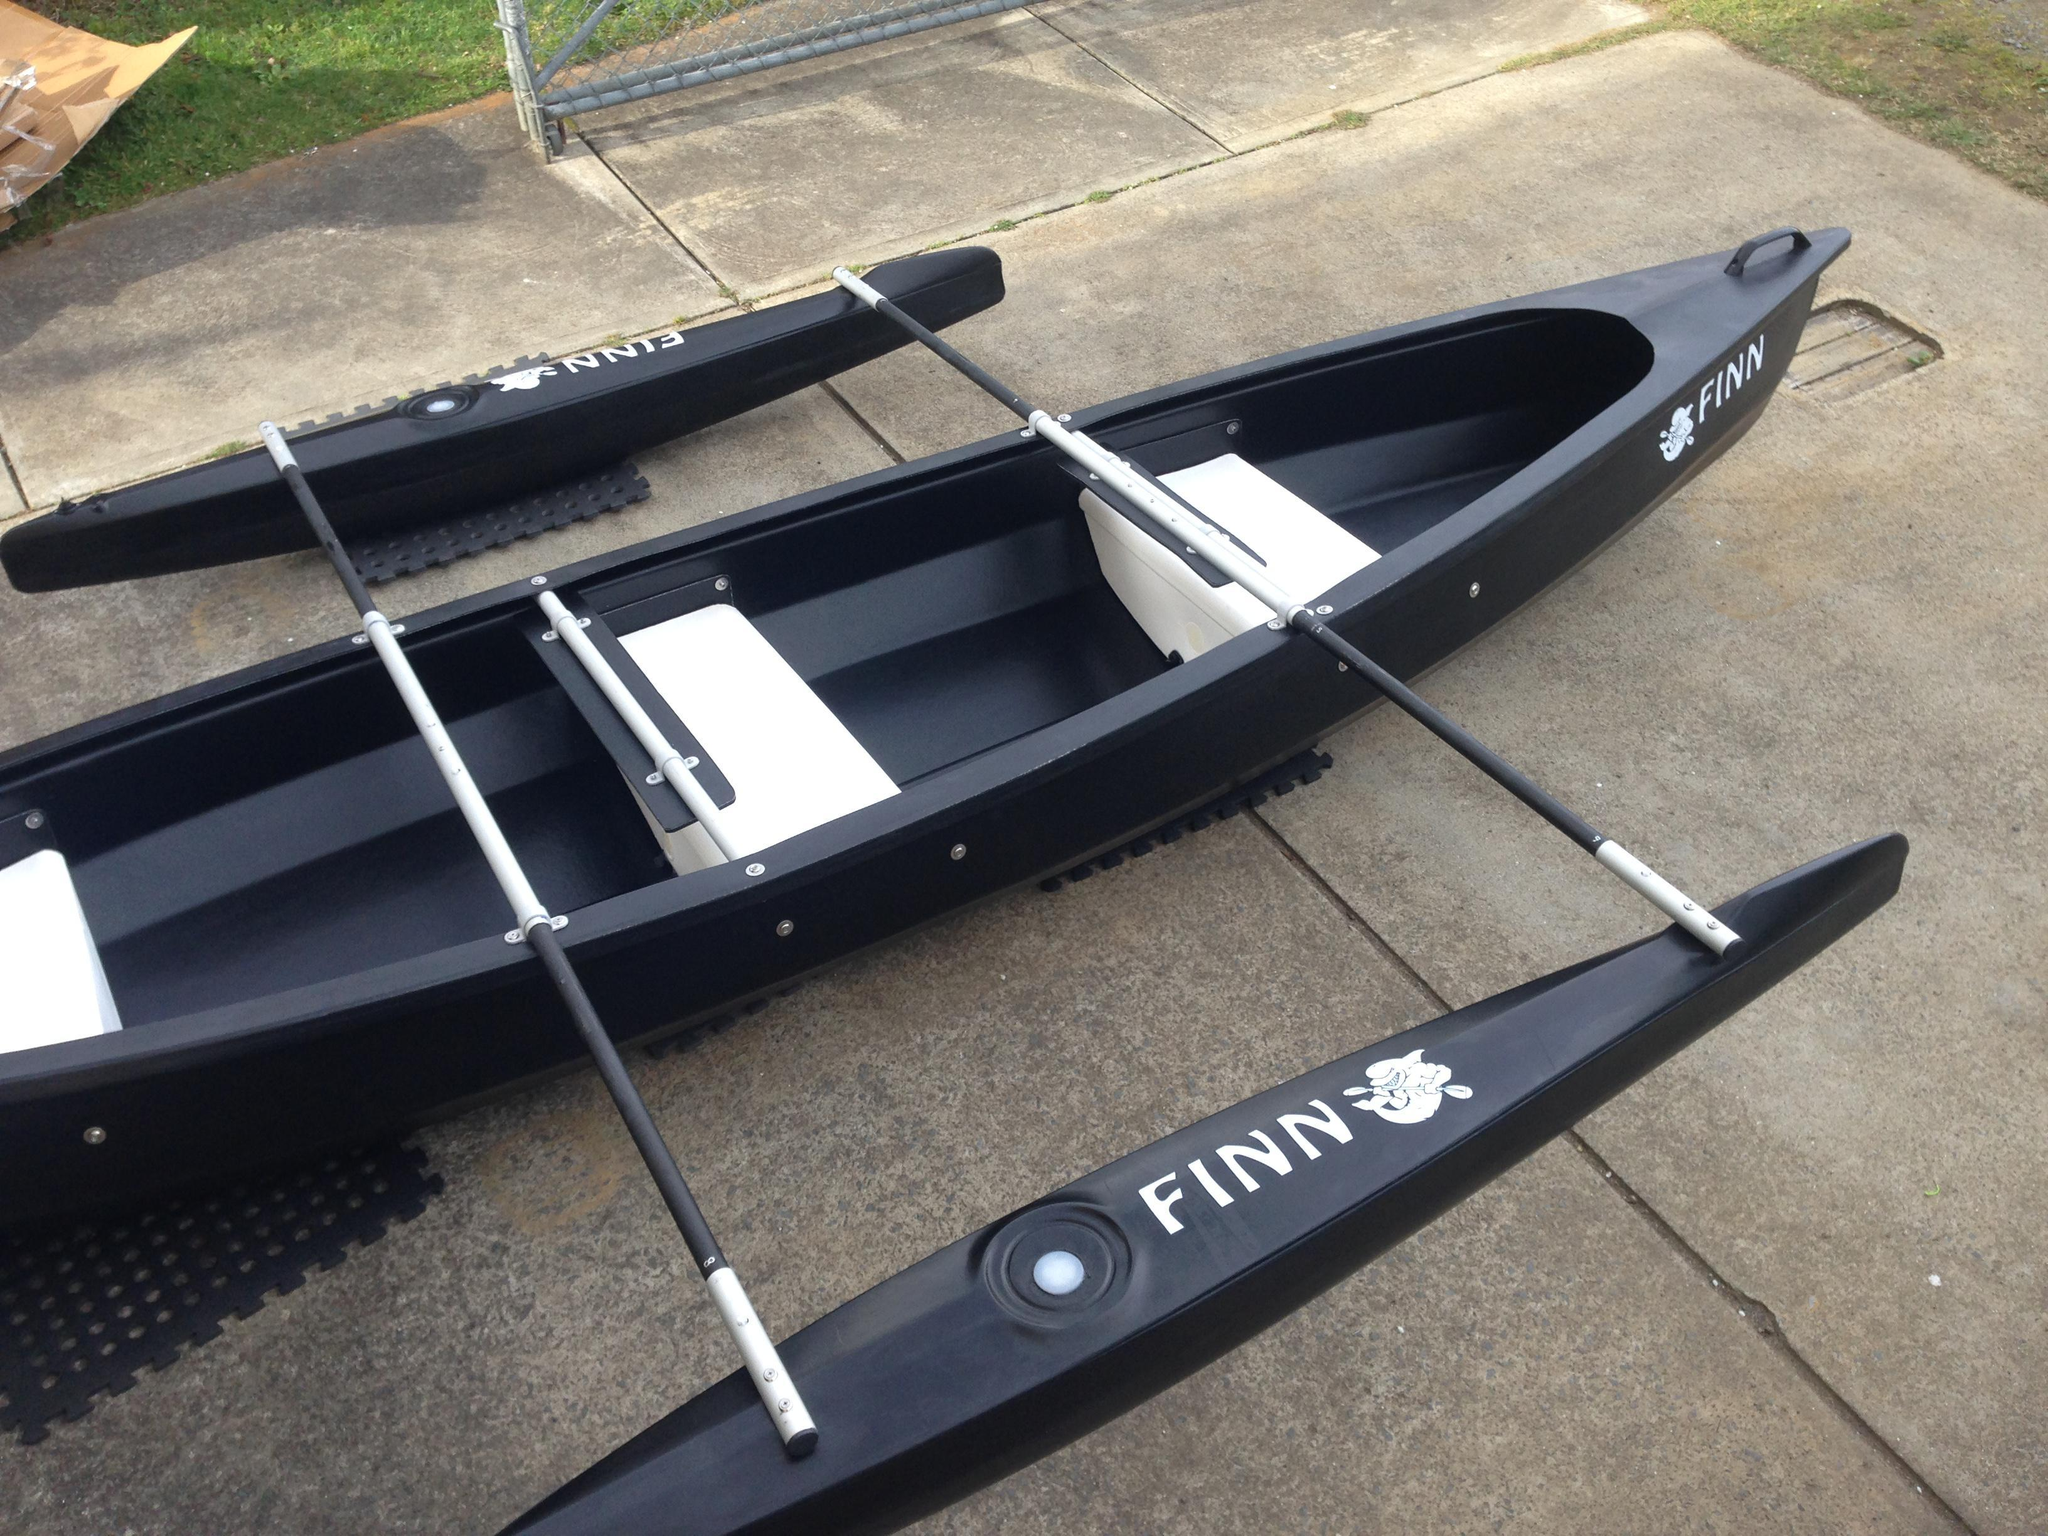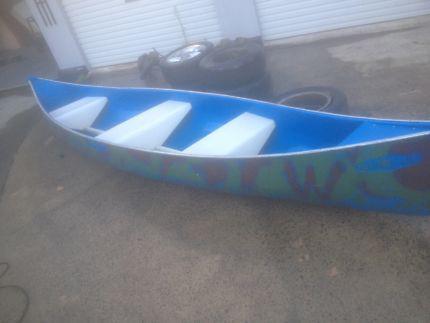The first image is the image on the left, the second image is the image on the right. Evaluate the accuracy of this statement regarding the images: "All of the canoes and kayaks have oars on them.". Is it true? Answer yes or no. No. The first image is the image on the left, the second image is the image on the right. For the images shown, is this caption "The left image has a red canoe with a paddle on it." true? Answer yes or no. No. 